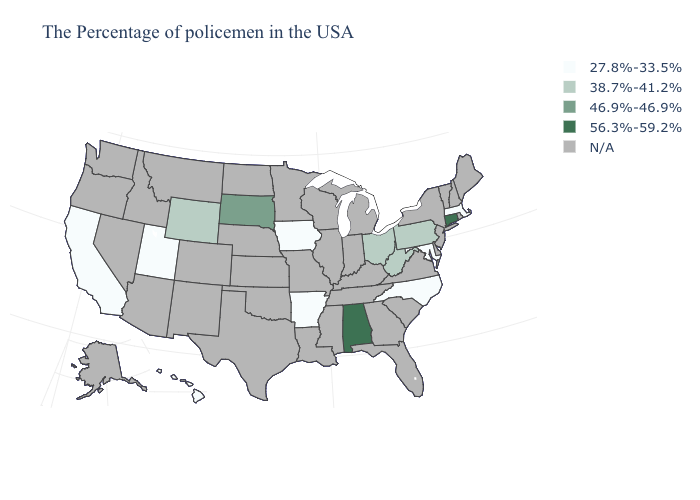What is the value of Louisiana?
Keep it brief. N/A. Does Alabama have the highest value in the South?
Give a very brief answer. Yes. What is the highest value in states that border Ohio?
Give a very brief answer. 38.7%-41.2%. What is the highest value in the Northeast ?
Be succinct. 56.3%-59.2%. What is the value of North Carolina?
Concise answer only. 27.8%-33.5%. Name the states that have a value in the range 46.9%-46.9%?
Answer briefly. South Dakota. What is the highest value in states that border Missouri?
Quick response, please. 27.8%-33.5%. What is the value of Ohio?
Answer briefly. 38.7%-41.2%. Does Arkansas have the highest value in the USA?
Give a very brief answer. No. What is the value of New Jersey?
Be succinct. N/A. What is the highest value in the MidWest ?
Short answer required. 46.9%-46.9%. 